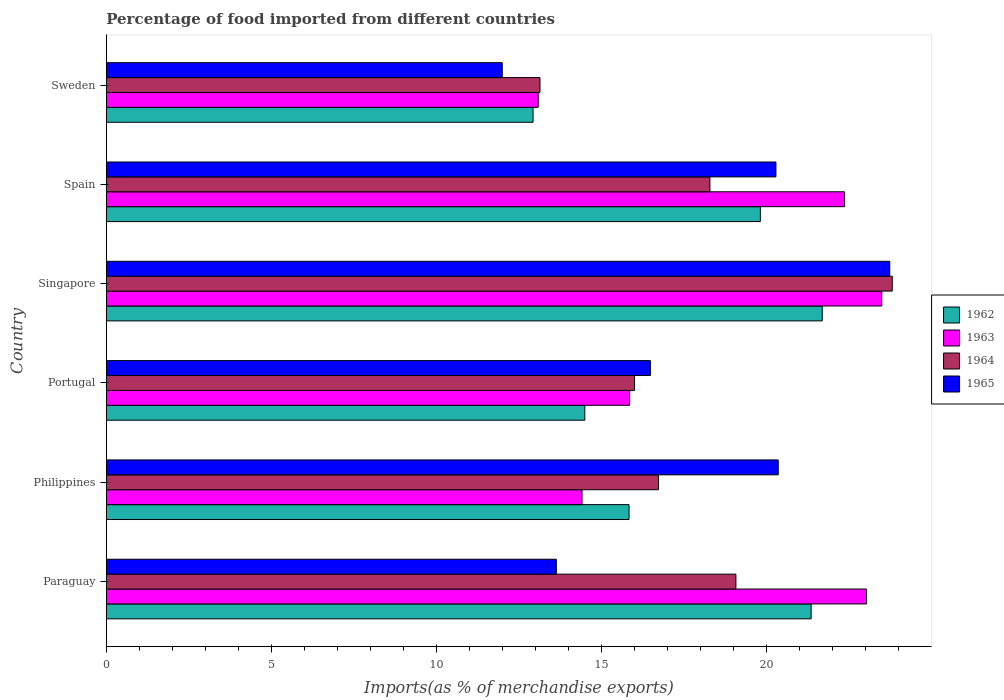Are the number of bars on each tick of the Y-axis equal?
Your answer should be very brief. Yes. How many bars are there on the 2nd tick from the top?
Keep it short and to the point. 4. How many bars are there on the 1st tick from the bottom?
Keep it short and to the point. 4. What is the percentage of imports to different countries in 1965 in Singapore?
Give a very brief answer. 23.73. Across all countries, what is the maximum percentage of imports to different countries in 1962?
Your answer should be compact. 21.69. Across all countries, what is the minimum percentage of imports to different countries in 1963?
Offer a very short reply. 13.08. In which country was the percentage of imports to different countries in 1965 maximum?
Provide a short and direct response. Singapore. What is the total percentage of imports to different countries in 1963 in the graph?
Offer a very short reply. 112.23. What is the difference between the percentage of imports to different countries in 1964 in Philippines and that in Portugal?
Give a very brief answer. 0.73. What is the difference between the percentage of imports to different countries in 1964 in Portugal and the percentage of imports to different countries in 1965 in Singapore?
Provide a succinct answer. -7.73. What is the average percentage of imports to different countries in 1963 per country?
Provide a succinct answer. 18.7. What is the difference between the percentage of imports to different countries in 1965 and percentage of imports to different countries in 1964 in Singapore?
Your answer should be compact. -0.08. In how many countries, is the percentage of imports to different countries in 1965 greater than 15 %?
Your answer should be compact. 4. What is the ratio of the percentage of imports to different countries in 1964 in Philippines to that in Portugal?
Your answer should be very brief. 1.05. Is the difference between the percentage of imports to different countries in 1965 in Paraguay and Philippines greater than the difference between the percentage of imports to different countries in 1964 in Paraguay and Philippines?
Your response must be concise. No. What is the difference between the highest and the second highest percentage of imports to different countries in 1964?
Give a very brief answer. 4.74. What is the difference between the highest and the lowest percentage of imports to different countries in 1965?
Offer a very short reply. 11.74. Is the sum of the percentage of imports to different countries in 1965 in Singapore and Sweden greater than the maximum percentage of imports to different countries in 1962 across all countries?
Your answer should be very brief. Yes. What does the 4th bar from the top in Spain represents?
Offer a terse response. 1962. What does the 3rd bar from the bottom in Sweden represents?
Offer a very short reply. 1964. Is it the case that in every country, the sum of the percentage of imports to different countries in 1964 and percentage of imports to different countries in 1962 is greater than the percentage of imports to different countries in 1963?
Ensure brevity in your answer.  Yes. Does the graph contain any zero values?
Give a very brief answer. No. Does the graph contain grids?
Provide a short and direct response. No. Where does the legend appear in the graph?
Offer a very short reply. Center right. How many legend labels are there?
Your response must be concise. 4. What is the title of the graph?
Keep it short and to the point. Percentage of food imported from different countries. Does "2011" appear as one of the legend labels in the graph?
Ensure brevity in your answer.  No. What is the label or title of the X-axis?
Your response must be concise. Imports(as % of merchandise exports). What is the Imports(as % of merchandise exports) of 1962 in Paraguay?
Offer a very short reply. 21.35. What is the Imports(as % of merchandise exports) in 1963 in Paraguay?
Your answer should be very brief. 23.03. What is the Imports(as % of merchandise exports) in 1964 in Paraguay?
Give a very brief answer. 19.07. What is the Imports(as % of merchandise exports) in 1965 in Paraguay?
Offer a very short reply. 13.63. What is the Imports(as % of merchandise exports) in 1962 in Philippines?
Give a very brief answer. 15.83. What is the Imports(as % of merchandise exports) in 1963 in Philippines?
Keep it short and to the point. 14.41. What is the Imports(as % of merchandise exports) in 1964 in Philippines?
Offer a terse response. 16.73. What is the Imports(as % of merchandise exports) of 1965 in Philippines?
Provide a short and direct response. 20.35. What is the Imports(as % of merchandise exports) of 1962 in Portugal?
Your answer should be very brief. 14.49. What is the Imports(as % of merchandise exports) in 1963 in Portugal?
Offer a very short reply. 15.85. What is the Imports(as % of merchandise exports) in 1964 in Portugal?
Your answer should be compact. 16. What is the Imports(as % of merchandise exports) in 1965 in Portugal?
Keep it short and to the point. 16.48. What is the Imports(as % of merchandise exports) of 1962 in Singapore?
Your answer should be compact. 21.69. What is the Imports(as % of merchandise exports) of 1963 in Singapore?
Provide a succinct answer. 23.49. What is the Imports(as % of merchandise exports) in 1964 in Singapore?
Keep it short and to the point. 23.81. What is the Imports(as % of merchandise exports) in 1965 in Singapore?
Provide a short and direct response. 23.73. What is the Imports(as % of merchandise exports) of 1962 in Spain?
Your answer should be very brief. 19.81. What is the Imports(as % of merchandise exports) in 1963 in Spain?
Your answer should be compact. 22.36. What is the Imports(as % of merchandise exports) in 1964 in Spain?
Your response must be concise. 18.28. What is the Imports(as % of merchandise exports) in 1965 in Spain?
Your answer should be very brief. 20.28. What is the Imports(as % of merchandise exports) of 1962 in Sweden?
Your response must be concise. 12.93. What is the Imports(as % of merchandise exports) in 1963 in Sweden?
Ensure brevity in your answer.  13.08. What is the Imports(as % of merchandise exports) in 1964 in Sweden?
Your answer should be compact. 13.14. What is the Imports(as % of merchandise exports) in 1965 in Sweden?
Your response must be concise. 11.99. Across all countries, what is the maximum Imports(as % of merchandise exports) in 1962?
Provide a succinct answer. 21.69. Across all countries, what is the maximum Imports(as % of merchandise exports) in 1963?
Your answer should be compact. 23.49. Across all countries, what is the maximum Imports(as % of merchandise exports) in 1964?
Your response must be concise. 23.81. Across all countries, what is the maximum Imports(as % of merchandise exports) of 1965?
Your answer should be compact. 23.73. Across all countries, what is the minimum Imports(as % of merchandise exports) of 1962?
Offer a very short reply. 12.93. Across all countries, what is the minimum Imports(as % of merchandise exports) in 1963?
Keep it short and to the point. 13.08. Across all countries, what is the minimum Imports(as % of merchandise exports) in 1964?
Provide a short and direct response. 13.14. Across all countries, what is the minimum Imports(as % of merchandise exports) in 1965?
Ensure brevity in your answer.  11.99. What is the total Imports(as % of merchandise exports) in 1962 in the graph?
Give a very brief answer. 106.11. What is the total Imports(as % of merchandise exports) of 1963 in the graph?
Make the answer very short. 112.23. What is the total Imports(as % of merchandise exports) in 1964 in the graph?
Ensure brevity in your answer.  107.02. What is the total Imports(as % of merchandise exports) of 1965 in the graph?
Your answer should be very brief. 106.48. What is the difference between the Imports(as % of merchandise exports) of 1962 in Paraguay and that in Philippines?
Offer a terse response. 5.52. What is the difference between the Imports(as % of merchandise exports) of 1963 in Paraguay and that in Philippines?
Offer a terse response. 8.62. What is the difference between the Imports(as % of merchandise exports) in 1964 in Paraguay and that in Philippines?
Ensure brevity in your answer.  2.35. What is the difference between the Imports(as % of merchandise exports) of 1965 in Paraguay and that in Philippines?
Your response must be concise. -6.72. What is the difference between the Imports(as % of merchandise exports) in 1962 in Paraguay and that in Portugal?
Your response must be concise. 6.86. What is the difference between the Imports(as % of merchandise exports) of 1963 in Paraguay and that in Portugal?
Offer a terse response. 7.18. What is the difference between the Imports(as % of merchandise exports) of 1964 in Paraguay and that in Portugal?
Make the answer very short. 3.07. What is the difference between the Imports(as % of merchandise exports) in 1965 in Paraguay and that in Portugal?
Your answer should be very brief. -2.85. What is the difference between the Imports(as % of merchandise exports) of 1962 in Paraguay and that in Singapore?
Provide a short and direct response. -0.34. What is the difference between the Imports(as % of merchandise exports) in 1963 in Paraguay and that in Singapore?
Offer a very short reply. -0.46. What is the difference between the Imports(as % of merchandise exports) of 1964 in Paraguay and that in Singapore?
Give a very brief answer. -4.74. What is the difference between the Imports(as % of merchandise exports) in 1965 in Paraguay and that in Singapore?
Keep it short and to the point. -10.1. What is the difference between the Imports(as % of merchandise exports) of 1962 in Paraguay and that in Spain?
Keep it short and to the point. 1.54. What is the difference between the Imports(as % of merchandise exports) in 1963 in Paraguay and that in Spain?
Make the answer very short. 0.66. What is the difference between the Imports(as % of merchandise exports) in 1964 in Paraguay and that in Spain?
Offer a terse response. 0.79. What is the difference between the Imports(as % of merchandise exports) of 1965 in Paraguay and that in Spain?
Ensure brevity in your answer.  -6.65. What is the difference between the Imports(as % of merchandise exports) of 1962 in Paraguay and that in Sweden?
Give a very brief answer. 8.42. What is the difference between the Imports(as % of merchandise exports) in 1963 in Paraguay and that in Sweden?
Ensure brevity in your answer.  9.95. What is the difference between the Imports(as % of merchandise exports) of 1964 in Paraguay and that in Sweden?
Ensure brevity in your answer.  5.94. What is the difference between the Imports(as % of merchandise exports) of 1965 in Paraguay and that in Sweden?
Offer a terse response. 1.64. What is the difference between the Imports(as % of merchandise exports) in 1962 in Philippines and that in Portugal?
Keep it short and to the point. 1.34. What is the difference between the Imports(as % of merchandise exports) in 1963 in Philippines and that in Portugal?
Your answer should be very brief. -1.44. What is the difference between the Imports(as % of merchandise exports) of 1964 in Philippines and that in Portugal?
Your response must be concise. 0.73. What is the difference between the Imports(as % of merchandise exports) in 1965 in Philippines and that in Portugal?
Give a very brief answer. 3.87. What is the difference between the Imports(as % of merchandise exports) in 1962 in Philippines and that in Singapore?
Your answer should be compact. -5.85. What is the difference between the Imports(as % of merchandise exports) of 1963 in Philippines and that in Singapore?
Ensure brevity in your answer.  -9.08. What is the difference between the Imports(as % of merchandise exports) in 1964 in Philippines and that in Singapore?
Provide a succinct answer. -7.08. What is the difference between the Imports(as % of merchandise exports) of 1965 in Philippines and that in Singapore?
Keep it short and to the point. -3.38. What is the difference between the Imports(as % of merchandise exports) of 1962 in Philippines and that in Spain?
Offer a terse response. -3.98. What is the difference between the Imports(as % of merchandise exports) in 1963 in Philippines and that in Spain?
Keep it short and to the point. -7.96. What is the difference between the Imports(as % of merchandise exports) in 1964 in Philippines and that in Spain?
Ensure brevity in your answer.  -1.56. What is the difference between the Imports(as % of merchandise exports) of 1965 in Philippines and that in Spain?
Your response must be concise. 0.07. What is the difference between the Imports(as % of merchandise exports) of 1962 in Philippines and that in Sweden?
Offer a very short reply. 2.91. What is the difference between the Imports(as % of merchandise exports) of 1963 in Philippines and that in Sweden?
Your answer should be very brief. 1.33. What is the difference between the Imports(as % of merchandise exports) of 1964 in Philippines and that in Sweden?
Your answer should be very brief. 3.59. What is the difference between the Imports(as % of merchandise exports) in 1965 in Philippines and that in Sweden?
Your response must be concise. 8.36. What is the difference between the Imports(as % of merchandise exports) in 1962 in Portugal and that in Singapore?
Offer a terse response. -7.19. What is the difference between the Imports(as % of merchandise exports) of 1963 in Portugal and that in Singapore?
Make the answer very short. -7.64. What is the difference between the Imports(as % of merchandise exports) of 1964 in Portugal and that in Singapore?
Make the answer very short. -7.81. What is the difference between the Imports(as % of merchandise exports) of 1965 in Portugal and that in Singapore?
Your answer should be very brief. -7.25. What is the difference between the Imports(as % of merchandise exports) of 1962 in Portugal and that in Spain?
Your response must be concise. -5.32. What is the difference between the Imports(as % of merchandise exports) of 1963 in Portugal and that in Spain?
Provide a succinct answer. -6.51. What is the difference between the Imports(as % of merchandise exports) in 1964 in Portugal and that in Spain?
Your answer should be compact. -2.28. What is the difference between the Imports(as % of merchandise exports) in 1965 in Portugal and that in Spain?
Keep it short and to the point. -3.8. What is the difference between the Imports(as % of merchandise exports) in 1962 in Portugal and that in Sweden?
Ensure brevity in your answer.  1.57. What is the difference between the Imports(as % of merchandise exports) in 1963 in Portugal and that in Sweden?
Your answer should be very brief. 2.77. What is the difference between the Imports(as % of merchandise exports) of 1964 in Portugal and that in Sweden?
Provide a succinct answer. 2.86. What is the difference between the Imports(as % of merchandise exports) in 1965 in Portugal and that in Sweden?
Offer a terse response. 4.49. What is the difference between the Imports(as % of merchandise exports) in 1962 in Singapore and that in Spain?
Provide a short and direct response. 1.87. What is the difference between the Imports(as % of merchandise exports) of 1963 in Singapore and that in Spain?
Your answer should be very brief. 1.12. What is the difference between the Imports(as % of merchandise exports) in 1964 in Singapore and that in Spain?
Make the answer very short. 5.52. What is the difference between the Imports(as % of merchandise exports) in 1965 in Singapore and that in Spain?
Offer a very short reply. 3.45. What is the difference between the Imports(as % of merchandise exports) in 1962 in Singapore and that in Sweden?
Your response must be concise. 8.76. What is the difference between the Imports(as % of merchandise exports) of 1963 in Singapore and that in Sweden?
Offer a terse response. 10.41. What is the difference between the Imports(as % of merchandise exports) of 1964 in Singapore and that in Sweden?
Keep it short and to the point. 10.67. What is the difference between the Imports(as % of merchandise exports) of 1965 in Singapore and that in Sweden?
Offer a terse response. 11.74. What is the difference between the Imports(as % of merchandise exports) in 1962 in Spain and that in Sweden?
Your answer should be compact. 6.89. What is the difference between the Imports(as % of merchandise exports) in 1963 in Spain and that in Sweden?
Your answer should be very brief. 9.28. What is the difference between the Imports(as % of merchandise exports) in 1964 in Spain and that in Sweden?
Your answer should be compact. 5.15. What is the difference between the Imports(as % of merchandise exports) of 1965 in Spain and that in Sweden?
Offer a very short reply. 8.29. What is the difference between the Imports(as % of merchandise exports) of 1962 in Paraguay and the Imports(as % of merchandise exports) of 1963 in Philippines?
Give a very brief answer. 6.94. What is the difference between the Imports(as % of merchandise exports) of 1962 in Paraguay and the Imports(as % of merchandise exports) of 1964 in Philippines?
Keep it short and to the point. 4.62. What is the difference between the Imports(as % of merchandise exports) in 1963 in Paraguay and the Imports(as % of merchandise exports) in 1964 in Philippines?
Provide a short and direct response. 6.3. What is the difference between the Imports(as % of merchandise exports) in 1963 in Paraguay and the Imports(as % of merchandise exports) in 1965 in Philippines?
Offer a terse response. 2.67. What is the difference between the Imports(as % of merchandise exports) in 1964 in Paraguay and the Imports(as % of merchandise exports) in 1965 in Philippines?
Your answer should be very brief. -1.28. What is the difference between the Imports(as % of merchandise exports) in 1962 in Paraguay and the Imports(as % of merchandise exports) in 1963 in Portugal?
Your answer should be very brief. 5.5. What is the difference between the Imports(as % of merchandise exports) in 1962 in Paraguay and the Imports(as % of merchandise exports) in 1964 in Portugal?
Keep it short and to the point. 5.35. What is the difference between the Imports(as % of merchandise exports) of 1962 in Paraguay and the Imports(as % of merchandise exports) of 1965 in Portugal?
Provide a succinct answer. 4.87. What is the difference between the Imports(as % of merchandise exports) in 1963 in Paraguay and the Imports(as % of merchandise exports) in 1964 in Portugal?
Provide a short and direct response. 7.03. What is the difference between the Imports(as % of merchandise exports) in 1963 in Paraguay and the Imports(as % of merchandise exports) in 1965 in Portugal?
Your answer should be very brief. 6.55. What is the difference between the Imports(as % of merchandise exports) in 1964 in Paraguay and the Imports(as % of merchandise exports) in 1965 in Portugal?
Your answer should be very brief. 2.59. What is the difference between the Imports(as % of merchandise exports) of 1962 in Paraguay and the Imports(as % of merchandise exports) of 1963 in Singapore?
Your answer should be very brief. -2.14. What is the difference between the Imports(as % of merchandise exports) in 1962 in Paraguay and the Imports(as % of merchandise exports) in 1964 in Singapore?
Provide a succinct answer. -2.46. What is the difference between the Imports(as % of merchandise exports) in 1962 in Paraguay and the Imports(as % of merchandise exports) in 1965 in Singapore?
Ensure brevity in your answer.  -2.38. What is the difference between the Imports(as % of merchandise exports) in 1963 in Paraguay and the Imports(as % of merchandise exports) in 1964 in Singapore?
Offer a terse response. -0.78. What is the difference between the Imports(as % of merchandise exports) in 1963 in Paraguay and the Imports(as % of merchandise exports) in 1965 in Singapore?
Offer a very short reply. -0.7. What is the difference between the Imports(as % of merchandise exports) in 1964 in Paraguay and the Imports(as % of merchandise exports) in 1965 in Singapore?
Ensure brevity in your answer.  -4.66. What is the difference between the Imports(as % of merchandise exports) in 1962 in Paraguay and the Imports(as % of merchandise exports) in 1963 in Spain?
Give a very brief answer. -1.01. What is the difference between the Imports(as % of merchandise exports) of 1962 in Paraguay and the Imports(as % of merchandise exports) of 1964 in Spain?
Offer a terse response. 3.07. What is the difference between the Imports(as % of merchandise exports) in 1962 in Paraguay and the Imports(as % of merchandise exports) in 1965 in Spain?
Your answer should be very brief. 1.07. What is the difference between the Imports(as % of merchandise exports) of 1963 in Paraguay and the Imports(as % of merchandise exports) of 1964 in Spain?
Offer a terse response. 4.75. What is the difference between the Imports(as % of merchandise exports) in 1963 in Paraguay and the Imports(as % of merchandise exports) in 1965 in Spain?
Offer a terse response. 2.74. What is the difference between the Imports(as % of merchandise exports) in 1964 in Paraguay and the Imports(as % of merchandise exports) in 1965 in Spain?
Keep it short and to the point. -1.21. What is the difference between the Imports(as % of merchandise exports) in 1962 in Paraguay and the Imports(as % of merchandise exports) in 1963 in Sweden?
Offer a terse response. 8.27. What is the difference between the Imports(as % of merchandise exports) of 1962 in Paraguay and the Imports(as % of merchandise exports) of 1964 in Sweden?
Offer a very short reply. 8.21. What is the difference between the Imports(as % of merchandise exports) of 1962 in Paraguay and the Imports(as % of merchandise exports) of 1965 in Sweden?
Offer a very short reply. 9.36. What is the difference between the Imports(as % of merchandise exports) of 1963 in Paraguay and the Imports(as % of merchandise exports) of 1964 in Sweden?
Your answer should be compact. 9.89. What is the difference between the Imports(as % of merchandise exports) of 1963 in Paraguay and the Imports(as % of merchandise exports) of 1965 in Sweden?
Make the answer very short. 11.04. What is the difference between the Imports(as % of merchandise exports) in 1964 in Paraguay and the Imports(as % of merchandise exports) in 1965 in Sweden?
Your answer should be very brief. 7.08. What is the difference between the Imports(as % of merchandise exports) of 1962 in Philippines and the Imports(as % of merchandise exports) of 1963 in Portugal?
Your answer should be compact. -0.02. What is the difference between the Imports(as % of merchandise exports) in 1962 in Philippines and the Imports(as % of merchandise exports) in 1964 in Portugal?
Your answer should be compact. -0.16. What is the difference between the Imports(as % of merchandise exports) in 1962 in Philippines and the Imports(as % of merchandise exports) in 1965 in Portugal?
Your answer should be very brief. -0.65. What is the difference between the Imports(as % of merchandise exports) of 1963 in Philippines and the Imports(as % of merchandise exports) of 1964 in Portugal?
Your response must be concise. -1.59. What is the difference between the Imports(as % of merchandise exports) in 1963 in Philippines and the Imports(as % of merchandise exports) in 1965 in Portugal?
Provide a short and direct response. -2.07. What is the difference between the Imports(as % of merchandise exports) of 1964 in Philippines and the Imports(as % of merchandise exports) of 1965 in Portugal?
Ensure brevity in your answer.  0.24. What is the difference between the Imports(as % of merchandise exports) in 1962 in Philippines and the Imports(as % of merchandise exports) in 1963 in Singapore?
Your response must be concise. -7.65. What is the difference between the Imports(as % of merchandise exports) of 1962 in Philippines and the Imports(as % of merchandise exports) of 1964 in Singapore?
Offer a very short reply. -7.97. What is the difference between the Imports(as % of merchandise exports) of 1962 in Philippines and the Imports(as % of merchandise exports) of 1965 in Singapore?
Provide a short and direct response. -7.9. What is the difference between the Imports(as % of merchandise exports) in 1963 in Philippines and the Imports(as % of merchandise exports) in 1964 in Singapore?
Offer a very short reply. -9.4. What is the difference between the Imports(as % of merchandise exports) of 1963 in Philippines and the Imports(as % of merchandise exports) of 1965 in Singapore?
Keep it short and to the point. -9.32. What is the difference between the Imports(as % of merchandise exports) of 1964 in Philippines and the Imports(as % of merchandise exports) of 1965 in Singapore?
Your answer should be compact. -7.01. What is the difference between the Imports(as % of merchandise exports) in 1962 in Philippines and the Imports(as % of merchandise exports) in 1963 in Spain?
Offer a terse response. -6.53. What is the difference between the Imports(as % of merchandise exports) of 1962 in Philippines and the Imports(as % of merchandise exports) of 1964 in Spain?
Give a very brief answer. -2.45. What is the difference between the Imports(as % of merchandise exports) in 1962 in Philippines and the Imports(as % of merchandise exports) in 1965 in Spain?
Provide a succinct answer. -4.45. What is the difference between the Imports(as % of merchandise exports) of 1963 in Philippines and the Imports(as % of merchandise exports) of 1964 in Spain?
Provide a succinct answer. -3.87. What is the difference between the Imports(as % of merchandise exports) of 1963 in Philippines and the Imports(as % of merchandise exports) of 1965 in Spain?
Make the answer very short. -5.88. What is the difference between the Imports(as % of merchandise exports) of 1964 in Philippines and the Imports(as % of merchandise exports) of 1965 in Spain?
Ensure brevity in your answer.  -3.56. What is the difference between the Imports(as % of merchandise exports) in 1962 in Philippines and the Imports(as % of merchandise exports) in 1963 in Sweden?
Offer a very short reply. 2.75. What is the difference between the Imports(as % of merchandise exports) of 1962 in Philippines and the Imports(as % of merchandise exports) of 1964 in Sweden?
Provide a short and direct response. 2.7. What is the difference between the Imports(as % of merchandise exports) in 1962 in Philippines and the Imports(as % of merchandise exports) in 1965 in Sweden?
Keep it short and to the point. 3.84. What is the difference between the Imports(as % of merchandise exports) in 1963 in Philippines and the Imports(as % of merchandise exports) in 1964 in Sweden?
Offer a very short reply. 1.27. What is the difference between the Imports(as % of merchandise exports) of 1963 in Philippines and the Imports(as % of merchandise exports) of 1965 in Sweden?
Offer a terse response. 2.42. What is the difference between the Imports(as % of merchandise exports) in 1964 in Philippines and the Imports(as % of merchandise exports) in 1965 in Sweden?
Your answer should be very brief. 4.73. What is the difference between the Imports(as % of merchandise exports) of 1962 in Portugal and the Imports(as % of merchandise exports) of 1963 in Singapore?
Your answer should be compact. -8.99. What is the difference between the Imports(as % of merchandise exports) in 1962 in Portugal and the Imports(as % of merchandise exports) in 1964 in Singapore?
Offer a very short reply. -9.31. What is the difference between the Imports(as % of merchandise exports) of 1962 in Portugal and the Imports(as % of merchandise exports) of 1965 in Singapore?
Give a very brief answer. -9.24. What is the difference between the Imports(as % of merchandise exports) of 1963 in Portugal and the Imports(as % of merchandise exports) of 1964 in Singapore?
Keep it short and to the point. -7.96. What is the difference between the Imports(as % of merchandise exports) in 1963 in Portugal and the Imports(as % of merchandise exports) in 1965 in Singapore?
Make the answer very short. -7.88. What is the difference between the Imports(as % of merchandise exports) in 1964 in Portugal and the Imports(as % of merchandise exports) in 1965 in Singapore?
Provide a short and direct response. -7.73. What is the difference between the Imports(as % of merchandise exports) in 1962 in Portugal and the Imports(as % of merchandise exports) in 1963 in Spain?
Provide a succinct answer. -7.87. What is the difference between the Imports(as % of merchandise exports) of 1962 in Portugal and the Imports(as % of merchandise exports) of 1964 in Spain?
Keep it short and to the point. -3.79. What is the difference between the Imports(as % of merchandise exports) of 1962 in Portugal and the Imports(as % of merchandise exports) of 1965 in Spain?
Your response must be concise. -5.79. What is the difference between the Imports(as % of merchandise exports) of 1963 in Portugal and the Imports(as % of merchandise exports) of 1964 in Spain?
Your answer should be compact. -2.43. What is the difference between the Imports(as % of merchandise exports) in 1963 in Portugal and the Imports(as % of merchandise exports) in 1965 in Spain?
Your answer should be very brief. -4.43. What is the difference between the Imports(as % of merchandise exports) in 1964 in Portugal and the Imports(as % of merchandise exports) in 1965 in Spain?
Make the answer very short. -4.29. What is the difference between the Imports(as % of merchandise exports) of 1962 in Portugal and the Imports(as % of merchandise exports) of 1963 in Sweden?
Give a very brief answer. 1.41. What is the difference between the Imports(as % of merchandise exports) in 1962 in Portugal and the Imports(as % of merchandise exports) in 1964 in Sweden?
Your answer should be very brief. 1.36. What is the difference between the Imports(as % of merchandise exports) of 1962 in Portugal and the Imports(as % of merchandise exports) of 1965 in Sweden?
Make the answer very short. 2.5. What is the difference between the Imports(as % of merchandise exports) of 1963 in Portugal and the Imports(as % of merchandise exports) of 1964 in Sweden?
Offer a very short reply. 2.72. What is the difference between the Imports(as % of merchandise exports) in 1963 in Portugal and the Imports(as % of merchandise exports) in 1965 in Sweden?
Keep it short and to the point. 3.86. What is the difference between the Imports(as % of merchandise exports) in 1964 in Portugal and the Imports(as % of merchandise exports) in 1965 in Sweden?
Ensure brevity in your answer.  4.01. What is the difference between the Imports(as % of merchandise exports) in 1962 in Singapore and the Imports(as % of merchandise exports) in 1963 in Spain?
Offer a terse response. -0.68. What is the difference between the Imports(as % of merchandise exports) of 1962 in Singapore and the Imports(as % of merchandise exports) of 1964 in Spain?
Make the answer very short. 3.4. What is the difference between the Imports(as % of merchandise exports) in 1962 in Singapore and the Imports(as % of merchandise exports) in 1965 in Spain?
Make the answer very short. 1.4. What is the difference between the Imports(as % of merchandise exports) in 1963 in Singapore and the Imports(as % of merchandise exports) in 1964 in Spain?
Your response must be concise. 5.21. What is the difference between the Imports(as % of merchandise exports) of 1963 in Singapore and the Imports(as % of merchandise exports) of 1965 in Spain?
Ensure brevity in your answer.  3.2. What is the difference between the Imports(as % of merchandise exports) in 1964 in Singapore and the Imports(as % of merchandise exports) in 1965 in Spain?
Offer a terse response. 3.52. What is the difference between the Imports(as % of merchandise exports) in 1962 in Singapore and the Imports(as % of merchandise exports) in 1963 in Sweden?
Ensure brevity in your answer.  8.6. What is the difference between the Imports(as % of merchandise exports) in 1962 in Singapore and the Imports(as % of merchandise exports) in 1964 in Sweden?
Offer a very short reply. 8.55. What is the difference between the Imports(as % of merchandise exports) of 1962 in Singapore and the Imports(as % of merchandise exports) of 1965 in Sweden?
Keep it short and to the point. 9.69. What is the difference between the Imports(as % of merchandise exports) in 1963 in Singapore and the Imports(as % of merchandise exports) in 1964 in Sweden?
Make the answer very short. 10.35. What is the difference between the Imports(as % of merchandise exports) in 1963 in Singapore and the Imports(as % of merchandise exports) in 1965 in Sweden?
Make the answer very short. 11.5. What is the difference between the Imports(as % of merchandise exports) of 1964 in Singapore and the Imports(as % of merchandise exports) of 1965 in Sweden?
Ensure brevity in your answer.  11.81. What is the difference between the Imports(as % of merchandise exports) of 1962 in Spain and the Imports(as % of merchandise exports) of 1963 in Sweden?
Ensure brevity in your answer.  6.73. What is the difference between the Imports(as % of merchandise exports) in 1962 in Spain and the Imports(as % of merchandise exports) in 1964 in Sweden?
Your answer should be very brief. 6.68. What is the difference between the Imports(as % of merchandise exports) in 1962 in Spain and the Imports(as % of merchandise exports) in 1965 in Sweden?
Offer a terse response. 7.82. What is the difference between the Imports(as % of merchandise exports) in 1963 in Spain and the Imports(as % of merchandise exports) in 1964 in Sweden?
Keep it short and to the point. 9.23. What is the difference between the Imports(as % of merchandise exports) of 1963 in Spain and the Imports(as % of merchandise exports) of 1965 in Sweden?
Give a very brief answer. 10.37. What is the difference between the Imports(as % of merchandise exports) of 1964 in Spain and the Imports(as % of merchandise exports) of 1965 in Sweden?
Your response must be concise. 6.29. What is the average Imports(as % of merchandise exports) in 1962 per country?
Make the answer very short. 17.68. What is the average Imports(as % of merchandise exports) in 1963 per country?
Keep it short and to the point. 18.7. What is the average Imports(as % of merchandise exports) of 1964 per country?
Offer a very short reply. 17.84. What is the average Imports(as % of merchandise exports) of 1965 per country?
Your answer should be compact. 17.75. What is the difference between the Imports(as % of merchandise exports) of 1962 and Imports(as % of merchandise exports) of 1963 in Paraguay?
Provide a short and direct response. -1.68. What is the difference between the Imports(as % of merchandise exports) in 1962 and Imports(as % of merchandise exports) in 1964 in Paraguay?
Give a very brief answer. 2.28. What is the difference between the Imports(as % of merchandise exports) of 1962 and Imports(as % of merchandise exports) of 1965 in Paraguay?
Your response must be concise. 7.72. What is the difference between the Imports(as % of merchandise exports) of 1963 and Imports(as % of merchandise exports) of 1964 in Paraguay?
Give a very brief answer. 3.96. What is the difference between the Imports(as % of merchandise exports) of 1963 and Imports(as % of merchandise exports) of 1965 in Paraguay?
Keep it short and to the point. 9.4. What is the difference between the Imports(as % of merchandise exports) of 1964 and Imports(as % of merchandise exports) of 1965 in Paraguay?
Offer a very short reply. 5.44. What is the difference between the Imports(as % of merchandise exports) of 1962 and Imports(as % of merchandise exports) of 1963 in Philippines?
Make the answer very short. 1.43. What is the difference between the Imports(as % of merchandise exports) of 1962 and Imports(as % of merchandise exports) of 1964 in Philippines?
Make the answer very short. -0.89. What is the difference between the Imports(as % of merchandise exports) in 1962 and Imports(as % of merchandise exports) in 1965 in Philippines?
Provide a short and direct response. -4.52. What is the difference between the Imports(as % of merchandise exports) in 1963 and Imports(as % of merchandise exports) in 1964 in Philippines?
Your answer should be very brief. -2.32. What is the difference between the Imports(as % of merchandise exports) in 1963 and Imports(as % of merchandise exports) in 1965 in Philippines?
Your response must be concise. -5.94. What is the difference between the Imports(as % of merchandise exports) of 1964 and Imports(as % of merchandise exports) of 1965 in Philippines?
Your answer should be very brief. -3.63. What is the difference between the Imports(as % of merchandise exports) in 1962 and Imports(as % of merchandise exports) in 1963 in Portugal?
Your answer should be very brief. -1.36. What is the difference between the Imports(as % of merchandise exports) in 1962 and Imports(as % of merchandise exports) in 1964 in Portugal?
Give a very brief answer. -1.5. What is the difference between the Imports(as % of merchandise exports) in 1962 and Imports(as % of merchandise exports) in 1965 in Portugal?
Make the answer very short. -1.99. What is the difference between the Imports(as % of merchandise exports) in 1963 and Imports(as % of merchandise exports) in 1964 in Portugal?
Your answer should be very brief. -0.15. What is the difference between the Imports(as % of merchandise exports) in 1963 and Imports(as % of merchandise exports) in 1965 in Portugal?
Your response must be concise. -0.63. What is the difference between the Imports(as % of merchandise exports) in 1964 and Imports(as % of merchandise exports) in 1965 in Portugal?
Keep it short and to the point. -0.48. What is the difference between the Imports(as % of merchandise exports) in 1962 and Imports(as % of merchandise exports) in 1963 in Singapore?
Make the answer very short. -1.8. What is the difference between the Imports(as % of merchandise exports) of 1962 and Imports(as % of merchandise exports) of 1964 in Singapore?
Your answer should be compact. -2.12. What is the difference between the Imports(as % of merchandise exports) in 1962 and Imports(as % of merchandise exports) in 1965 in Singapore?
Make the answer very short. -2.04. What is the difference between the Imports(as % of merchandise exports) in 1963 and Imports(as % of merchandise exports) in 1964 in Singapore?
Your answer should be very brief. -0.32. What is the difference between the Imports(as % of merchandise exports) of 1963 and Imports(as % of merchandise exports) of 1965 in Singapore?
Your response must be concise. -0.24. What is the difference between the Imports(as % of merchandise exports) in 1964 and Imports(as % of merchandise exports) in 1965 in Singapore?
Give a very brief answer. 0.08. What is the difference between the Imports(as % of merchandise exports) of 1962 and Imports(as % of merchandise exports) of 1963 in Spain?
Provide a short and direct response. -2.55. What is the difference between the Imports(as % of merchandise exports) of 1962 and Imports(as % of merchandise exports) of 1964 in Spain?
Give a very brief answer. 1.53. What is the difference between the Imports(as % of merchandise exports) in 1962 and Imports(as % of merchandise exports) in 1965 in Spain?
Ensure brevity in your answer.  -0.47. What is the difference between the Imports(as % of merchandise exports) in 1963 and Imports(as % of merchandise exports) in 1964 in Spain?
Your answer should be very brief. 4.08. What is the difference between the Imports(as % of merchandise exports) of 1963 and Imports(as % of merchandise exports) of 1965 in Spain?
Make the answer very short. 2.08. What is the difference between the Imports(as % of merchandise exports) in 1964 and Imports(as % of merchandise exports) in 1965 in Spain?
Give a very brief answer. -2. What is the difference between the Imports(as % of merchandise exports) of 1962 and Imports(as % of merchandise exports) of 1963 in Sweden?
Offer a very short reply. -0.16. What is the difference between the Imports(as % of merchandise exports) in 1962 and Imports(as % of merchandise exports) in 1964 in Sweden?
Make the answer very short. -0.21. What is the difference between the Imports(as % of merchandise exports) of 1962 and Imports(as % of merchandise exports) of 1965 in Sweden?
Your answer should be compact. 0.93. What is the difference between the Imports(as % of merchandise exports) of 1963 and Imports(as % of merchandise exports) of 1964 in Sweden?
Provide a short and direct response. -0.05. What is the difference between the Imports(as % of merchandise exports) of 1963 and Imports(as % of merchandise exports) of 1965 in Sweden?
Your response must be concise. 1.09. What is the difference between the Imports(as % of merchandise exports) in 1964 and Imports(as % of merchandise exports) in 1965 in Sweden?
Offer a terse response. 1.14. What is the ratio of the Imports(as % of merchandise exports) of 1962 in Paraguay to that in Philippines?
Your answer should be compact. 1.35. What is the ratio of the Imports(as % of merchandise exports) in 1963 in Paraguay to that in Philippines?
Provide a succinct answer. 1.6. What is the ratio of the Imports(as % of merchandise exports) in 1964 in Paraguay to that in Philippines?
Keep it short and to the point. 1.14. What is the ratio of the Imports(as % of merchandise exports) in 1965 in Paraguay to that in Philippines?
Give a very brief answer. 0.67. What is the ratio of the Imports(as % of merchandise exports) of 1962 in Paraguay to that in Portugal?
Give a very brief answer. 1.47. What is the ratio of the Imports(as % of merchandise exports) of 1963 in Paraguay to that in Portugal?
Provide a succinct answer. 1.45. What is the ratio of the Imports(as % of merchandise exports) in 1964 in Paraguay to that in Portugal?
Your answer should be very brief. 1.19. What is the ratio of the Imports(as % of merchandise exports) of 1965 in Paraguay to that in Portugal?
Ensure brevity in your answer.  0.83. What is the ratio of the Imports(as % of merchandise exports) in 1962 in Paraguay to that in Singapore?
Provide a succinct answer. 0.98. What is the ratio of the Imports(as % of merchandise exports) in 1963 in Paraguay to that in Singapore?
Provide a succinct answer. 0.98. What is the ratio of the Imports(as % of merchandise exports) in 1964 in Paraguay to that in Singapore?
Give a very brief answer. 0.8. What is the ratio of the Imports(as % of merchandise exports) in 1965 in Paraguay to that in Singapore?
Your answer should be very brief. 0.57. What is the ratio of the Imports(as % of merchandise exports) in 1962 in Paraguay to that in Spain?
Keep it short and to the point. 1.08. What is the ratio of the Imports(as % of merchandise exports) of 1963 in Paraguay to that in Spain?
Make the answer very short. 1.03. What is the ratio of the Imports(as % of merchandise exports) of 1964 in Paraguay to that in Spain?
Offer a very short reply. 1.04. What is the ratio of the Imports(as % of merchandise exports) in 1965 in Paraguay to that in Spain?
Offer a terse response. 0.67. What is the ratio of the Imports(as % of merchandise exports) in 1962 in Paraguay to that in Sweden?
Ensure brevity in your answer.  1.65. What is the ratio of the Imports(as % of merchandise exports) in 1963 in Paraguay to that in Sweden?
Make the answer very short. 1.76. What is the ratio of the Imports(as % of merchandise exports) in 1964 in Paraguay to that in Sweden?
Your answer should be compact. 1.45. What is the ratio of the Imports(as % of merchandise exports) in 1965 in Paraguay to that in Sweden?
Offer a very short reply. 1.14. What is the ratio of the Imports(as % of merchandise exports) in 1962 in Philippines to that in Portugal?
Make the answer very short. 1.09. What is the ratio of the Imports(as % of merchandise exports) in 1963 in Philippines to that in Portugal?
Provide a short and direct response. 0.91. What is the ratio of the Imports(as % of merchandise exports) in 1964 in Philippines to that in Portugal?
Your answer should be very brief. 1.05. What is the ratio of the Imports(as % of merchandise exports) in 1965 in Philippines to that in Portugal?
Ensure brevity in your answer.  1.24. What is the ratio of the Imports(as % of merchandise exports) in 1962 in Philippines to that in Singapore?
Ensure brevity in your answer.  0.73. What is the ratio of the Imports(as % of merchandise exports) in 1963 in Philippines to that in Singapore?
Offer a terse response. 0.61. What is the ratio of the Imports(as % of merchandise exports) of 1964 in Philippines to that in Singapore?
Provide a succinct answer. 0.7. What is the ratio of the Imports(as % of merchandise exports) in 1965 in Philippines to that in Singapore?
Offer a very short reply. 0.86. What is the ratio of the Imports(as % of merchandise exports) of 1962 in Philippines to that in Spain?
Ensure brevity in your answer.  0.8. What is the ratio of the Imports(as % of merchandise exports) of 1963 in Philippines to that in Spain?
Make the answer very short. 0.64. What is the ratio of the Imports(as % of merchandise exports) in 1964 in Philippines to that in Spain?
Your response must be concise. 0.91. What is the ratio of the Imports(as % of merchandise exports) of 1965 in Philippines to that in Spain?
Provide a short and direct response. 1. What is the ratio of the Imports(as % of merchandise exports) of 1962 in Philippines to that in Sweden?
Give a very brief answer. 1.22. What is the ratio of the Imports(as % of merchandise exports) in 1963 in Philippines to that in Sweden?
Offer a very short reply. 1.1. What is the ratio of the Imports(as % of merchandise exports) in 1964 in Philippines to that in Sweden?
Provide a succinct answer. 1.27. What is the ratio of the Imports(as % of merchandise exports) in 1965 in Philippines to that in Sweden?
Give a very brief answer. 1.7. What is the ratio of the Imports(as % of merchandise exports) of 1962 in Portugal to that in Singapore?
Your answer should be compact. 0.67. What is the ratio of the Imports(as % of merchandise exports) of 1963 in Portugal to that in Singapore?
Your answer should be compact. 0.67. What is the ratio of the Imports(as % of merchandise exports) in 1964 in Portugal to that in Singapore?
Make the answer very short. 0.67. What is the ratio of the Imports(as % of merchandise exports) of 1965 in Portugal to that in Singapore?
Give a very brief answer. 0.69. What is the ratio of the Imports(as % of merchandise exports) in 1962 in Portugal to that in Spain?
Provide a short and direct response. 0.73. What is the ratio of the Imports(as % of merchandise exports) of 1963 in Portugal to that in Spain?
Your answer should be compact. 0.71. What is the ratio of the Imports(as % of merchandise exports) in 1965 in Portugal to that in Spain?
Keep it short and to the point. 0.81. What is the ratio of the Imports(as % of merchandise exports) of 1962 in Portugal to that in Sweden?
Ensure brevity in your answer.  1.12. What is the ratio of the Imports(as % of merchandise exports) in 1963 in Portugal to that in Sweden?
Ensure brevity in your answer.  1.21. What is the ratio of the Imports(as % of merchandise exports) in 1964 in Portugal to that in Sweden?
Give a very brief answer. 1.22. What is the ratio of the Imports(as % of merchandise exports) in 1965 in Portugal to that in Sweden?
Your answer should be compact. 1.37. What is the ratio of the Imports(as % of merchandise exports) in 1962 in Singapore to that in Spain?
Ensure brevity in your answer.  1.09. What is the ratio of the Imports(as % of merchandise exports) in 1963 in Singapore to that in Spain?
Your answer should be compact. 1.05. What is the ratio of the Imports(as % of merchandise exports) in 1964 in Singapore to that in Spain?
Provide a succinct answer. 1.3. What is the ratio of the Imports(as % of merchandise exports) in 1965 in Singapore to that in Spain?
Provide a succinct answer. 1.17. What is the ratio of the Imports(as % of merchandise exports) in 1962 in Singapore to that in Sweden?
Offer a very short reply. 1.68. What is the ratio of the Imports(as % of merchandise exports) of 1963 in Singapore to that in Sweden?
Give a very brief answer. 1.8. What is the ratio of the Imports(as % of merchandise exports) of 1964 in Singapore to that in Sweden?
Keep it short and to the point. 1.81. What is the ratio of the Imports(as % of merchandise exports) in 1965 in Singapore to that in Sweden?
Offer a terse response. 1.98. What is the ratio of the Imports(as % of merchandise exports) in 1962 in Spain to that in Sweden?
Give a very brief answer. 1.53. What is the ratio of the Imports(as % of merchandise exports) in 1963 in Spain to that in Sweden?
Offer a very short reply. 1.71. What is the ratio of the Imports(as % of merchandise exports) in 1964 in Spain to that in Sweden?
Your answer should be very brief. 1.39. What is the ratio of the Imports(as % of merchandise exports) of 1965 in Spain to that in Sweden?
Your answer should be very brief. 1.69. What is the difference between the highest and the second highest Imports(as % of merchandise exports) of 1962?
Provide a short and direct response. 0.34. What is the difference between the highest and the second highest Imports(as % of merchandise exports) of 1963?
Ensure brevity in your answer.  0.46. What is the difference between the highest and the second highest Imports(as % of merchandise exports) of 1964?
Ensure brevity in your answer.  4.74. What is the difference between the highest and the second highest Imports(as % of merchandise exports) of 1965?
Ensure brevity in your answer.  3.38. What is the difference between the highest and the lowest Imports(as % of merchandise exports) in 1962?
Make the answer very short. 8.76. What is the difference between the highest and the lowest Imports(as % of merchandise exports) of 1963?
Offer a terse response. 10.41. What is the difference between the highest and the lowest Imports(as % of merchandise exports) in 1964?
Your response must be concise. 10.67. What is the difference between the highest and the lowest Imports(as % of merchandise exports) of 1965?
Offer a very short reply. 11.74. 